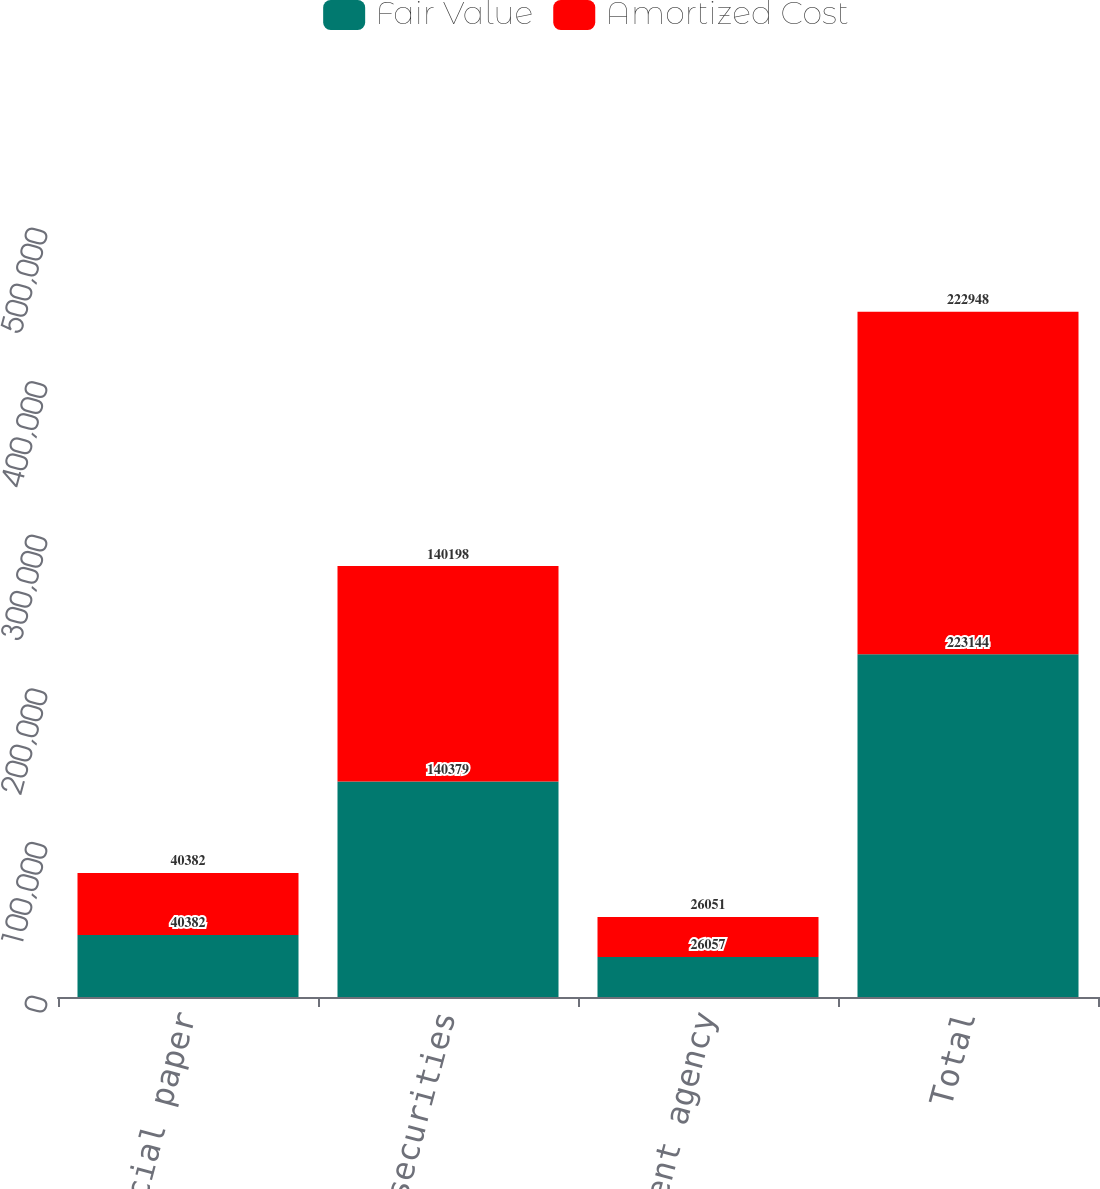Convert chart to OTSL. <chart><loc_0><loc_0><loc_500><loc_500><stacked_bar_chart><ecel><fcel>Commercial paper<fcel>Municipal securities<fcel>US government agency<fcel>Total<nl><fcel>Fair Value<fcel>40382<fcel>140379<fcel>26057<fcel>223144<nl><fcel>Amortized Cost<fcel>40382<fcel>140198<fcel>26051<fcel>222948<nl></chart> 